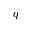Convert formula to latex. <formula><loc_0><loc_0><loc_500><loc_500>q</formula> 